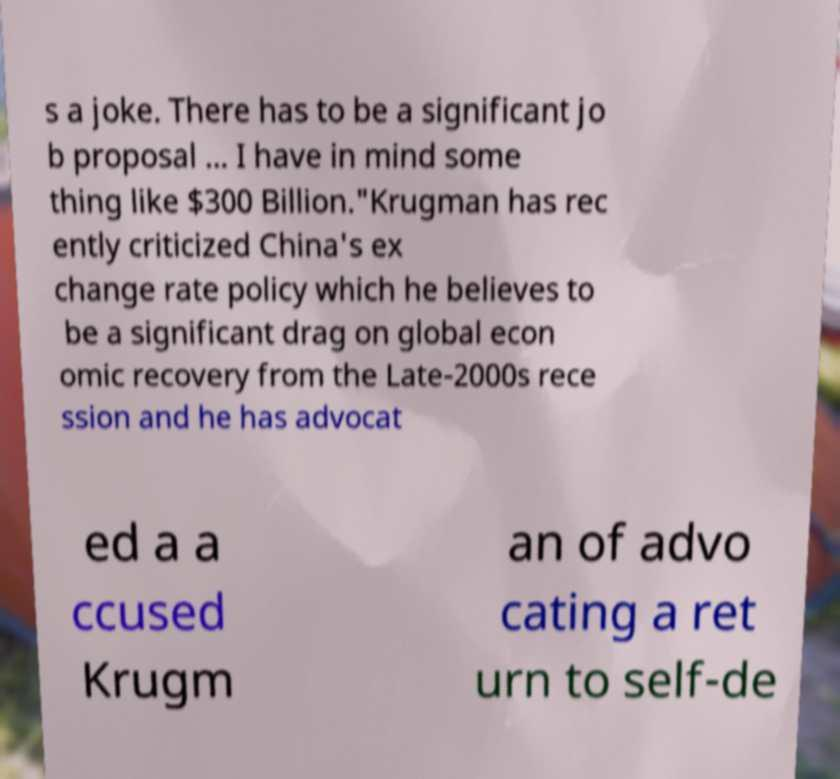Please read and relay the text visible in this image. What does it say? s a joke. There has to be a significant jo b proposal ... I have in mind some thing like $300 Billion."Krugman has rec ently criticized China's ex change rate policy which he believes to be a significant drag on global econ omic recovery from the Late-2000s rece ssion and he has advocat ed a a ccused Krugm an of advo cating a ret urn to self-de 